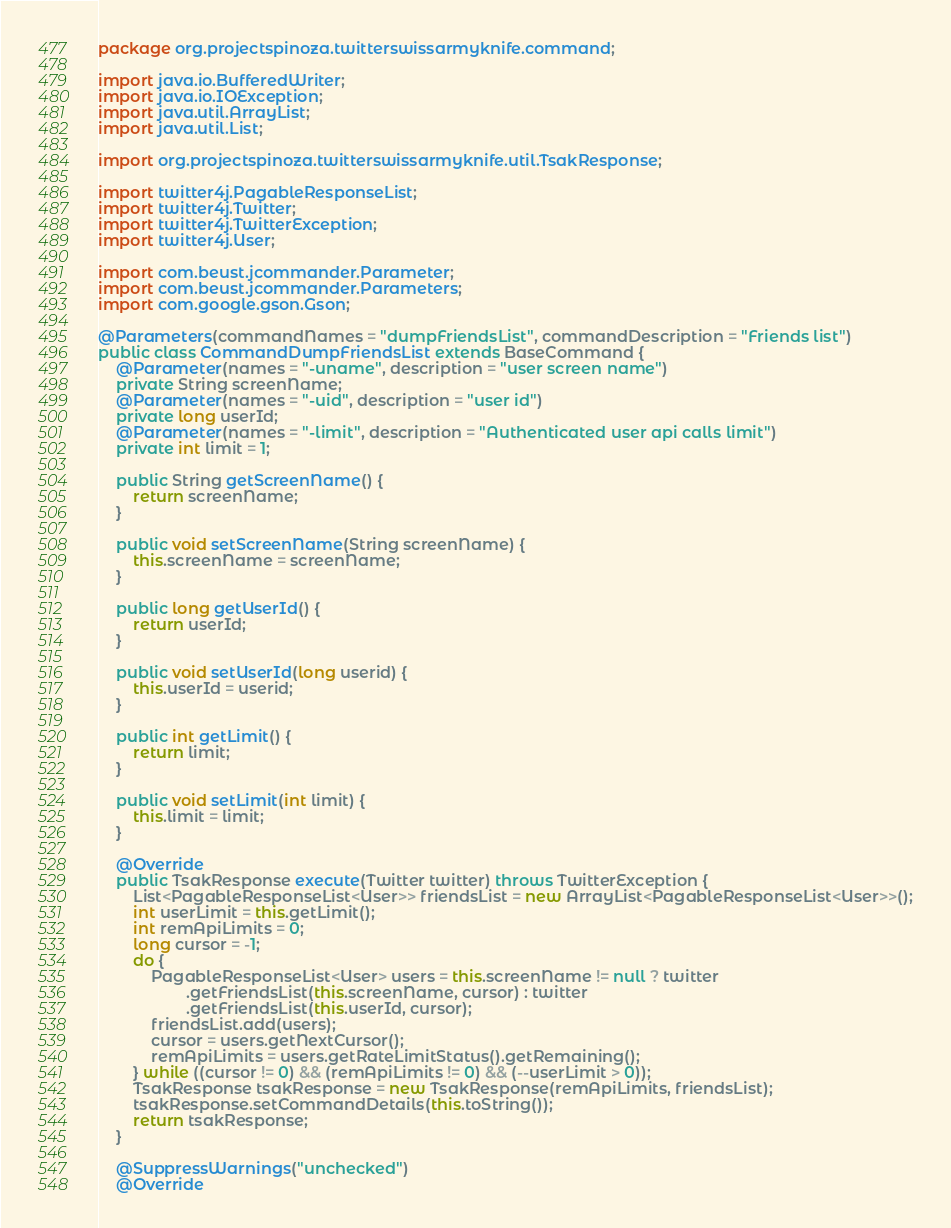<code> <loc_0><loc_0><loc_500><loc_500><_Java_>package org.projectspinoza.twitterswissarmyknife.command;

import java.io.BufferedWriter;
import java.io.IOException;
import java.util.ArrayList;
import java.util.List;

import org.projectspinoza.twitterswissarmyknife.util.TsakResponse;

import twitter4j.PagableResponseList;
import twitter4j.Twitter;
import twitter4j.TwitterException;
import twitter4j.User;

import com.beust.jcommander.Parameter;
import com.beust.jcommander.Parameters;
import com.google.gson.Gson;

@Parameters(commandNames = "dumpFriendsList", commandDescription = "Friends list")
public class CommandDumpFriendsList extends BaseCommand {
    @Parameter(names = "-uname", description = "user screen name")
    private String screenName;
    @Parameter(names = "-uid", description = "user id")
    private long userId;
    @Parameter(names = "-limit", description = "Authenticated user api calls limit")
    private int limit = 1;

    public String getScreenName() {
        return screenName;
    }

    public void setScreenName(String screenName) {
        this.screenName = screenName;
    }

    public long getUserId() {
        return userId;
    }

    public void setUserId(long userid) {
        this.userId = userid;
    }

    public int getLimit() {
        return limit;
    }

    public void setLimit(int limit) {
        this.limit = limit;
    }

    @Override
    public TsakResponse execute(Twitter twitter) throws TwitterException {
        List<PagableResponseList<User>> friendsList = new ArrayList<PagableResponseList<User>>();
        int userLimit = this.getLimit();
        int remApiLimits = 0;
        long cursor = -1;
        do {
            PagableResponseList<User> users = this.screenName != null ? twitter
                    .getFriendsList(this.screenName, cursor) : twitter
                    .getFriendsList(this.userId, cursor);
            friendsList.add(users);
            cursor = users.getNextCursor();
            remApiLimits = users.getRateLimitStatus().getRemaining();
        } while ((cursor != 0) && (remApiLimits != 0) && (--userLimit > 0));
        TsakResponse tsakResponse = new TsakResponse(remApiLimits, friendsList);
        tsakResponse.setCommandDetails(this.toString());
        return tsakResponse;
    }

    @SuppressWarnings("unchecked")
    @Override</code> 